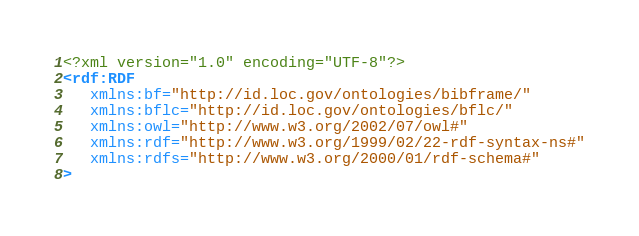Convert code to text. <code><loc_0><loc_0><loc_500><loc_500><_XML_><?xml version="1.0" encoding="UTF-8"?>
<rdf:RDF
   xmlns:bf="http://id.loc.gov/ontologies/bibframe/"
   xmlns:bflc="http://id.loc.gov/ontologies/bflc/"
   xmlns:owl="http://www.w3.org/2002/07/owl#"
   xmlns:rdf="http://www.w3.org/1999/02/22-rdf-syntax-ns#"
   xmlns:rdfs="http://www.w3.org/2000/01/rdf-schema#"
></code> 